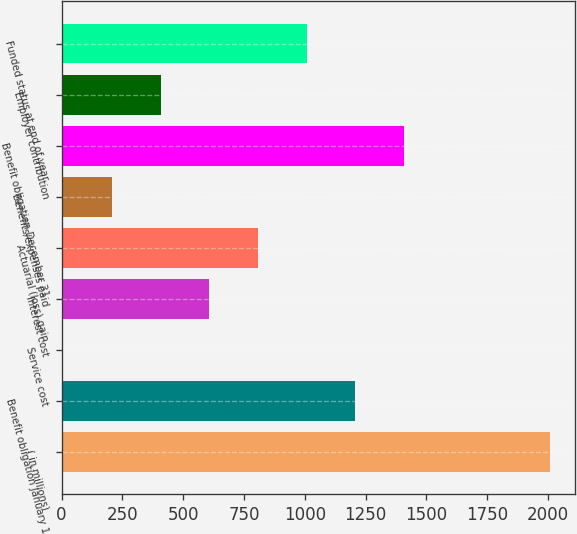<chart> <loc_0><loc_0><loc_500><loc_500><bar_chart><fcel>( in millions)<fcel>Benefit obligation January 1<fcel>Service cost<fcel>Interest cost<fcel>Actuarial (loss) gain<fcel>Benefits/expenses paid<fcel>Benefit obligation December 31<fcel>Employer contribution<fcel>Funded status at end of year<nl><fcel>2009<fcel>1208.52<fcel>7.8<fcel>608.16<fcel>808.28<fcel>207.92<fcel>1408.64<fcel>408.04<fcel>1008.4<nl></chart> 